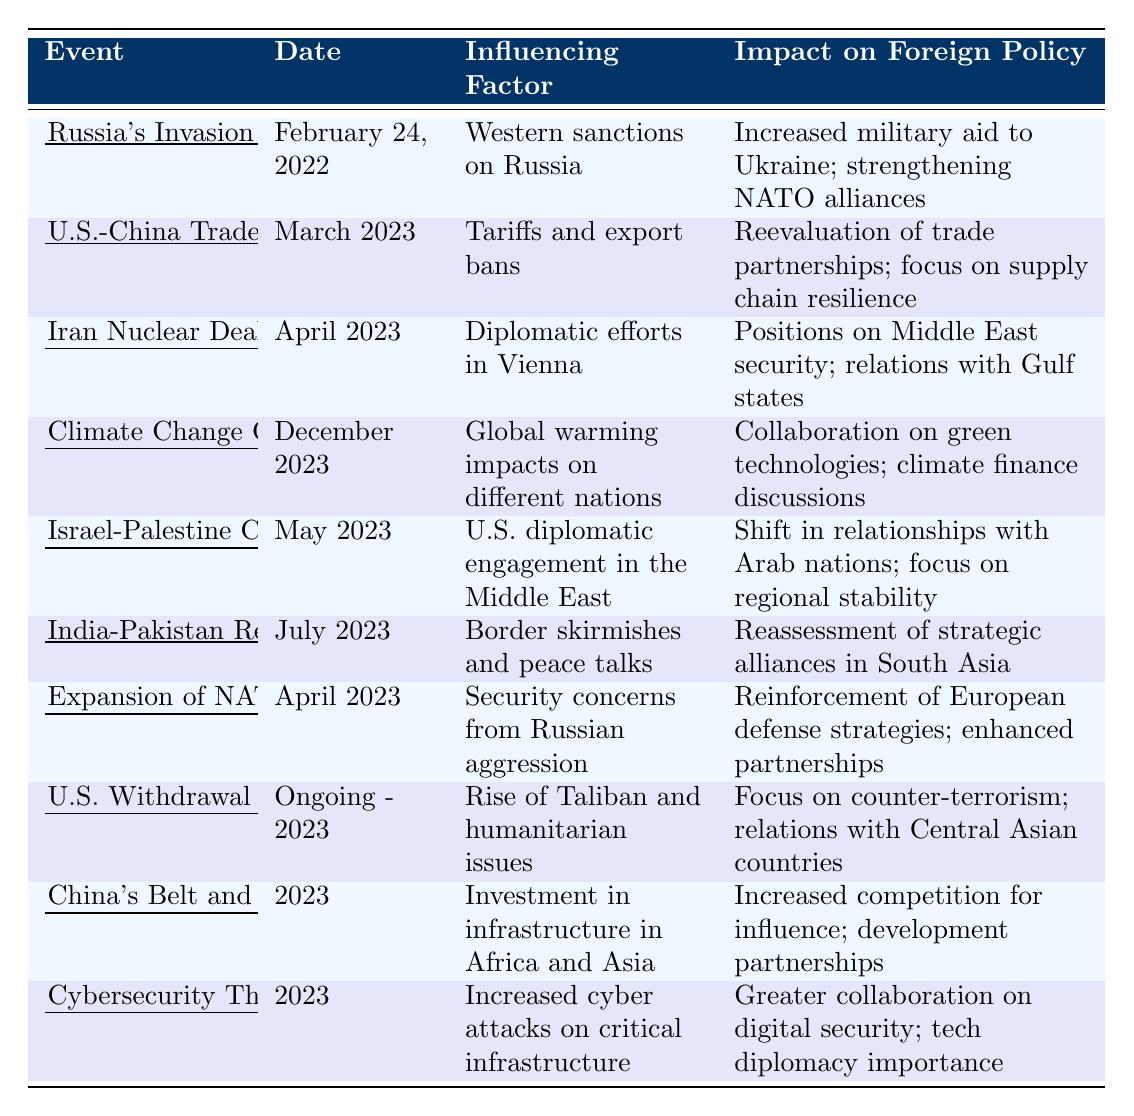What event occurred on February 24, 2022? The table lists "Russia's Invasion of Ukraine" as the event that occurred on that date.
Answer: Russia's Invasion of Ukraine Which geopolitical event is associated with tariffs and export bans? The event linked with tariffs and export bans is "U.S.-China Trade Tensions" noted in March 2023.
Answer: U.S.-China Trade Tensions How many events are recorded for the year 2023? The table shows 5 events listed specifically for the year 2023 (U.S.-China Trade Tensions, Climate Change Commitments at COP28, India-Pakistan Relations, China's Belt and Road Initiative Expansion, and Cybersecurity Threats and Responses).
Answer: 5 Is the "Israel-Palestine Ceasefire Agreement" influenced by U.S. diplomatic engagement? Yes, the influence is stated in the table as U.S. diplomatic engagement in the Middle East.
Answer: Yes What impact did the "Expansion of NATO to Finland and Sweden" have on European defense strategies? The table indicates the impact as "Reinforcement of European defense strategies; enhanced partnerships."
Answer: Reinforcement of European defense strategies Which event has the most direct relation to cyber security issues? The event related to cyber security issues is "Cybersecurity Threats and Responses" occurring in 2023.
Answer: Cybersecurity Threats and Responses Was there an impact on foreign policy regarding the Iran Nuclear Deal Negotiations? Yes, the impact stated in the table is on "Positions on Middle East security; relations with Gulf states."
Answer: Yes How did the "U.S. Withdrawal from Afghanistan Consequences" affect relations with Central Asian countries? The table notes that the focus is on counter-terrorism and relations with Central Asian countries as a consequence of the U.S. withdrawal.
Answer: Focus on counter-terrorism Which two events from 2023 are particularly focused on enhancing collaboration with specific regions or countries? The events are "Israel-Palestine Ceasefire Agreement," focused on Arab nations, and "Cybersecurity Threats and Responses," which deals with digital security partnerships globally. The collaboration is evident in both events, impacting their respective regions.
Answer: Israel-Palestine Ceasefire Agreement and Cybersecurity Threats and Responses What is the common theme of the events occurring in 2023 regarding international relations? The events in 2023 highlight an overall trend towards reevaluating alliances and enhancing security measures due to emerging threats (trade tensions, cyber threats) and cooperation (climate commitments). This theme is developed through various influencing factors impacting foreign policy.
Answer: Reevaluation of alliances and enhancing security measures 